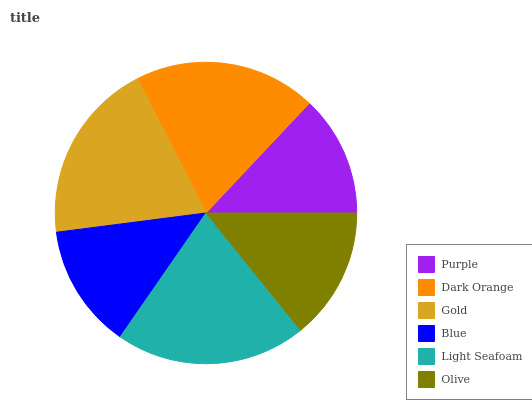Is Purple the minimum?
Answer yes or no. Yes. Is Light Seafoam the maximum?
Answer yes or no. Yes. Is Dark Orange the minimum?
Answer yes or no. No. Is Dark Orange the maximum?
Answer yes or no. No. Is Dark Orange greater than Purple?
Answer yes or no. Yes. Is Purple less than Dark Orange?
Answer yes or no. Yes. Is Purple greater than Dark Orange?
Answer yes or no. No. Is Dark Orange less than Purple?
Answer yes or no. No. Is Dark Orange the high median?
Answer yes or no. Yes. Is Olive the low median?
Answer yes or no. Yes. Is Blue the high median?
Answer yes or no. No. Is Dark Orange the low median?
Answer yes or no. No. 